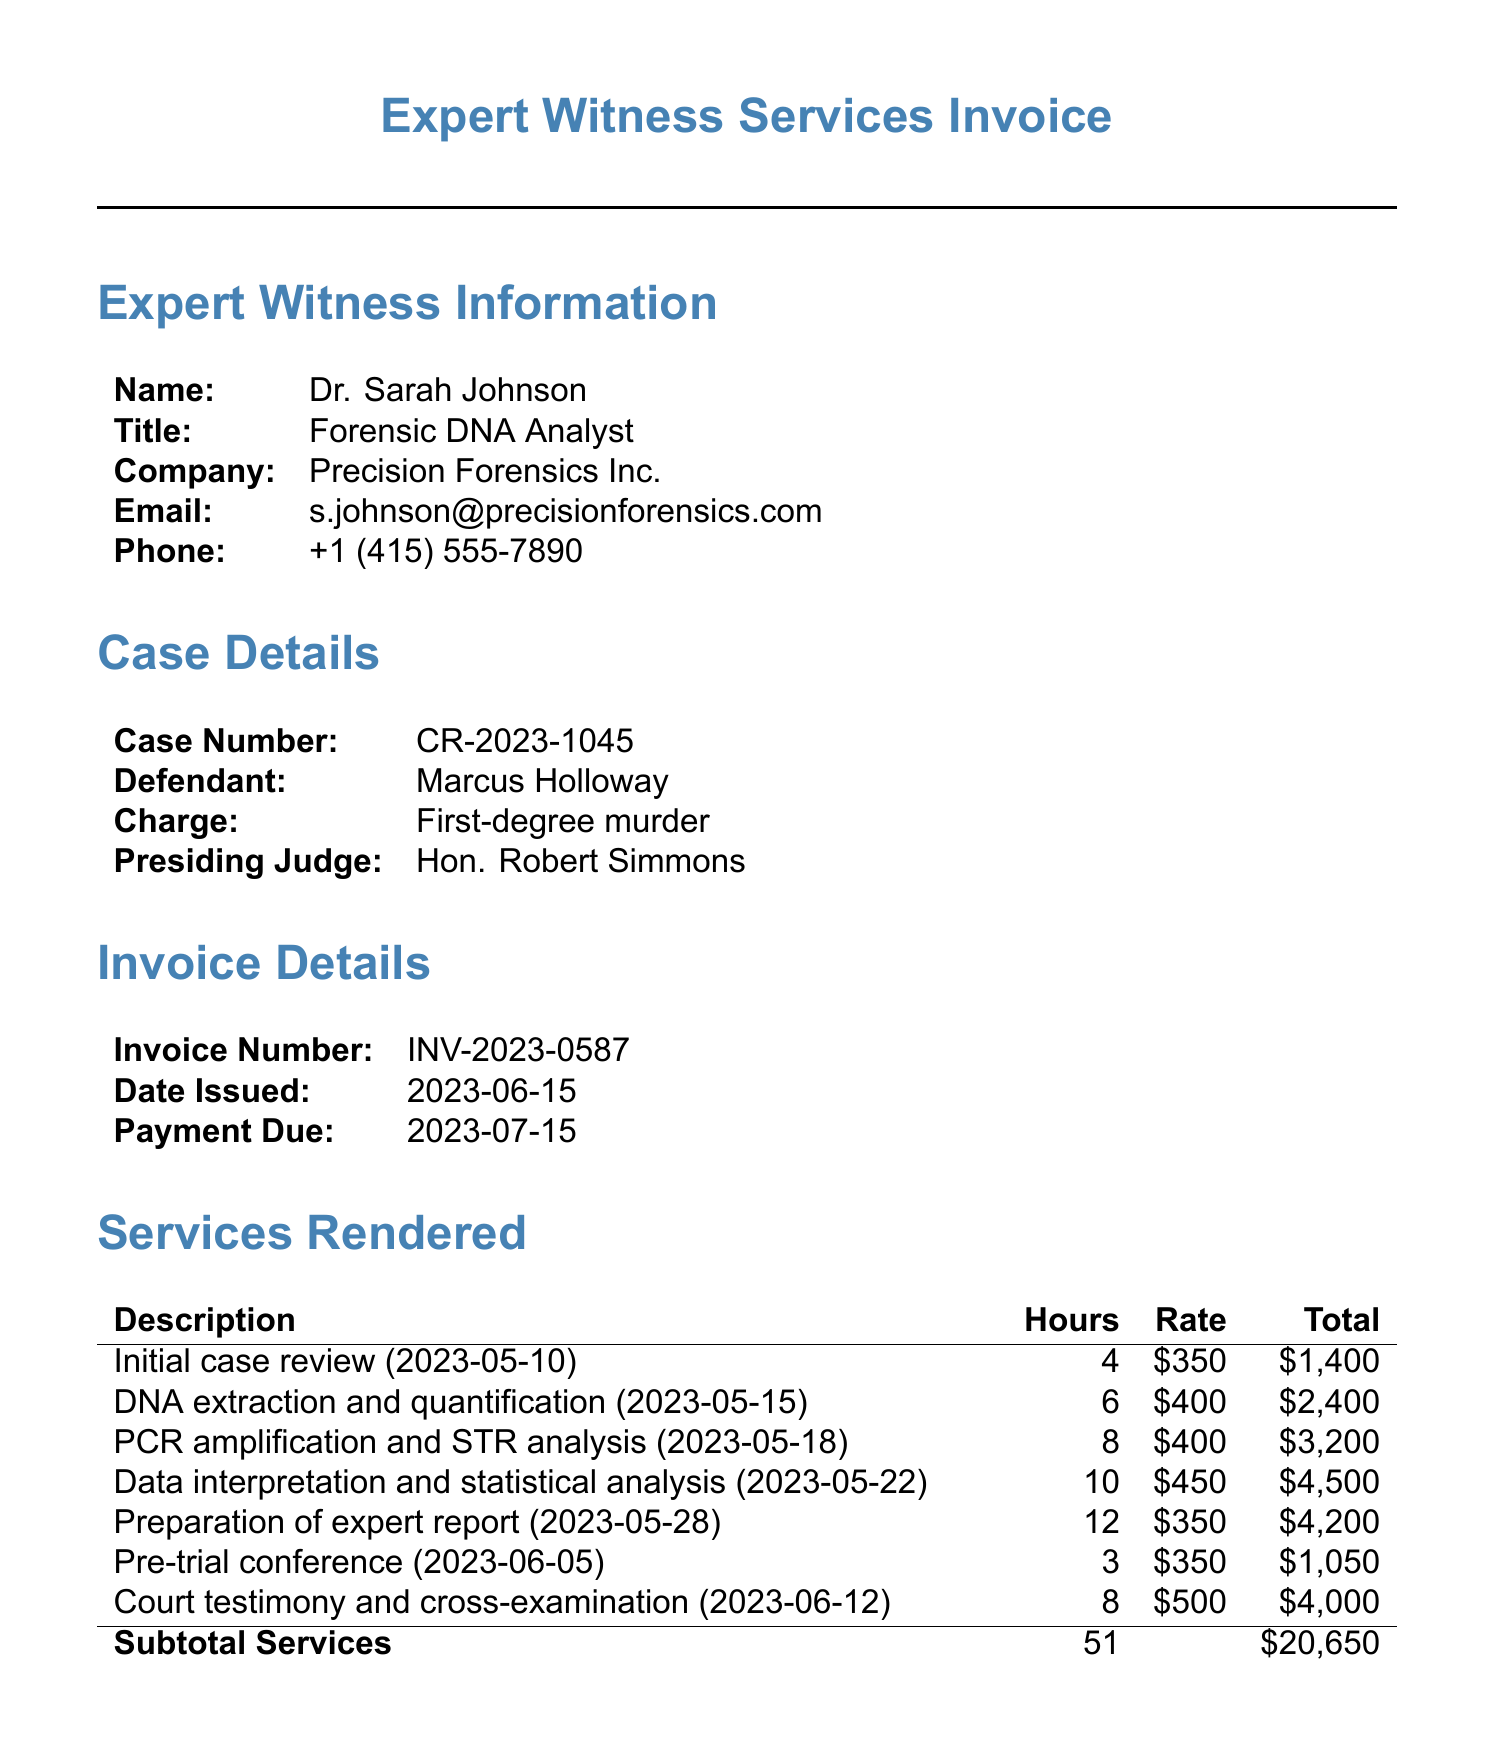What is the name of the expert witness? The document specifies the name of the expert witness as Dr. Sarah Johnson.
Answer: Dr. Sarah Johnson What is the total number of hours billed? The total hours listed in the document sum up to 51 hours of services rendered.
Answer: 51 What is the charge against the defendant? The document mentions that the defendant, Marcus Holloway, faces a charge of first-degree murder.
Answer: First-degree murder What is the rate for court testimony and cross-examination? The document indicates that the rate for court testimony and cross-examination is $500 per hour.
Answer: $500 When was the invoice issued? The invoice was issued on June 15, 2023, as specified in the document.
Answer: 2023-06-15 How much is the subtotal for services rendered? The document shows that the subtotal for services rendered amounts to $20,650.
Answer: $20,650 What is the due date for the payment? The payment due date is stated in the document as July 15, 2023.
Answer: 2023-07-15 How many hours were spent on data interpretation and statistical analysis? The document states that 10 hours were spent on data interpretation and statistical analysis.
Answer: 10 What is the total due amount for the invoice? The total due amount for the invoice is given as $23,700.
Answer: $23,700 